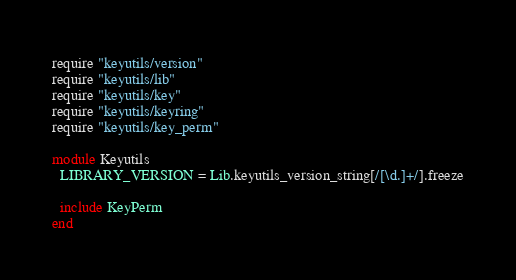Convert code to text. <code><loc_0><loc_0><loc_500><loc_500><_Ruby_>require "keyutils/version"
require "keyutils/lib"
require "keyutils/key"
require "keyutils/keyring"
require "keyutils/key_perm"

module Keyutils
  LIBRARY_VERSION = Lib.keyutils_version_string[/[\d.]+/].freeze

  include KeyPerm
end
</code> 